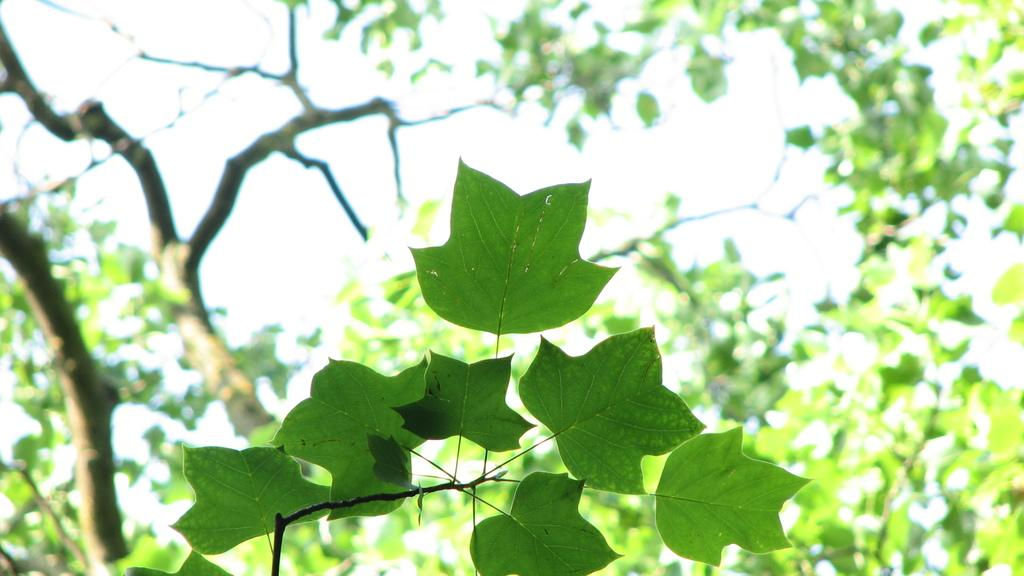What type of plant parts are visible in the image? There are leaves of a plant in the image. Where are the leaves located in the image? The leaves are on the down side of the image. What other natural element can be seen in the background of the image? There is a tree in the back side of the image. How many toes can be seen on the tree in the image? There are no toes visible in the image, as it features plant leaves and a tree, not any body parts. 